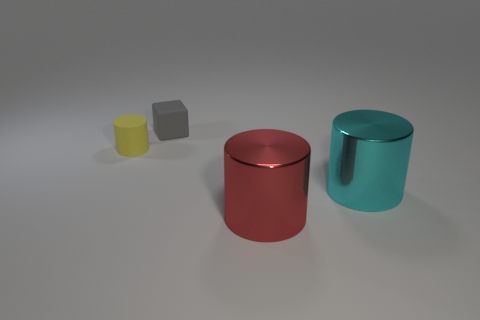What is the shape of the thing that is both behind the big cyan object and right of the small yellow cylinder?
Ensure brevity in your answer.  Cube. Are there any cylinders behind the red metallic thing?
Your answer should be compact. Yes. Is there any other thing that has the same shape as the tiny gray rubber object?
Provide a succinct answer. No. Do the red metal object and the yellow thing have the same shape?
Your answer should be compact. Yes. Are there an equal number of yellow matte cylinders in front of the cyan metallic thing and small cylinders in front of the small cylinder?
Provide a succinct answer. Yes. What number of other things are there of the same material as the big red thing
Offer a terse response. 1. What number of tiny objects are gray cubes or rubber objects?
Your answer should be compact. 2. Is the number of cyan metallic objects that are in front of the red object the same as the number of tiny green shiny spheres?
Ensure brevity in your answer.  Yes. Are there any small gray rubber objects right of the tiny object that is to the right of the small cylinder?
Make the answer very short. No. The tiny cylinder has what color?
Provide a short and direct response. Yellow. 